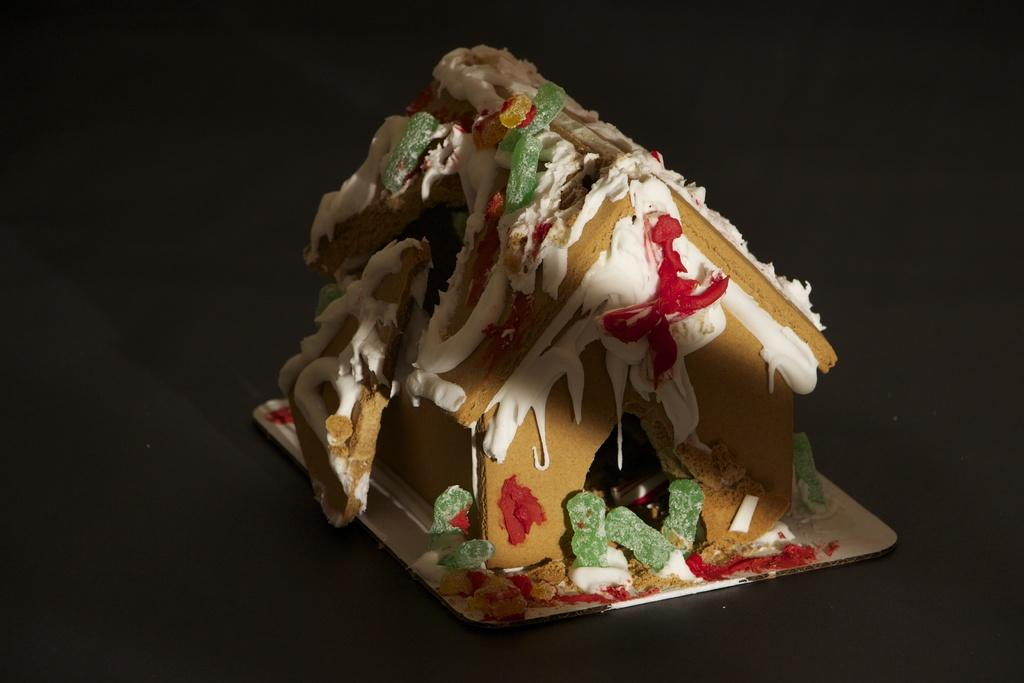What type of structure is present in the image? There is a small hut in the image. How does the hut resemble a food item? The hut resembles a food item, possibly a cake or pastry, due to its shape and decorative elements. What is the cream-like substance in the image? There appears to be cream in the image, which may be a part of the food item resembling the hut. What other sweet items are present in the image? There are candies in the image. What direction is the yak facing in the image? There is no yak present in the image. Is the canvas visible in the image? There is no canvas present in the image. 